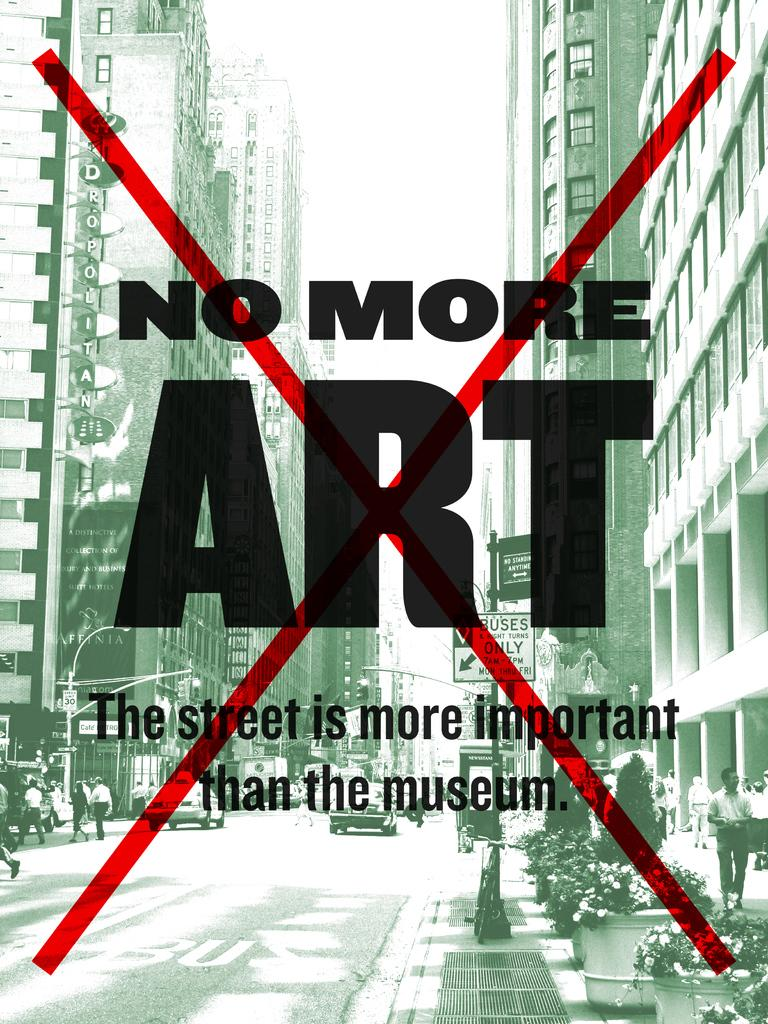<image>
Create a compact narrative representing the image presented. No More Art, The street is more important than the museum is shown on an activists poster. 